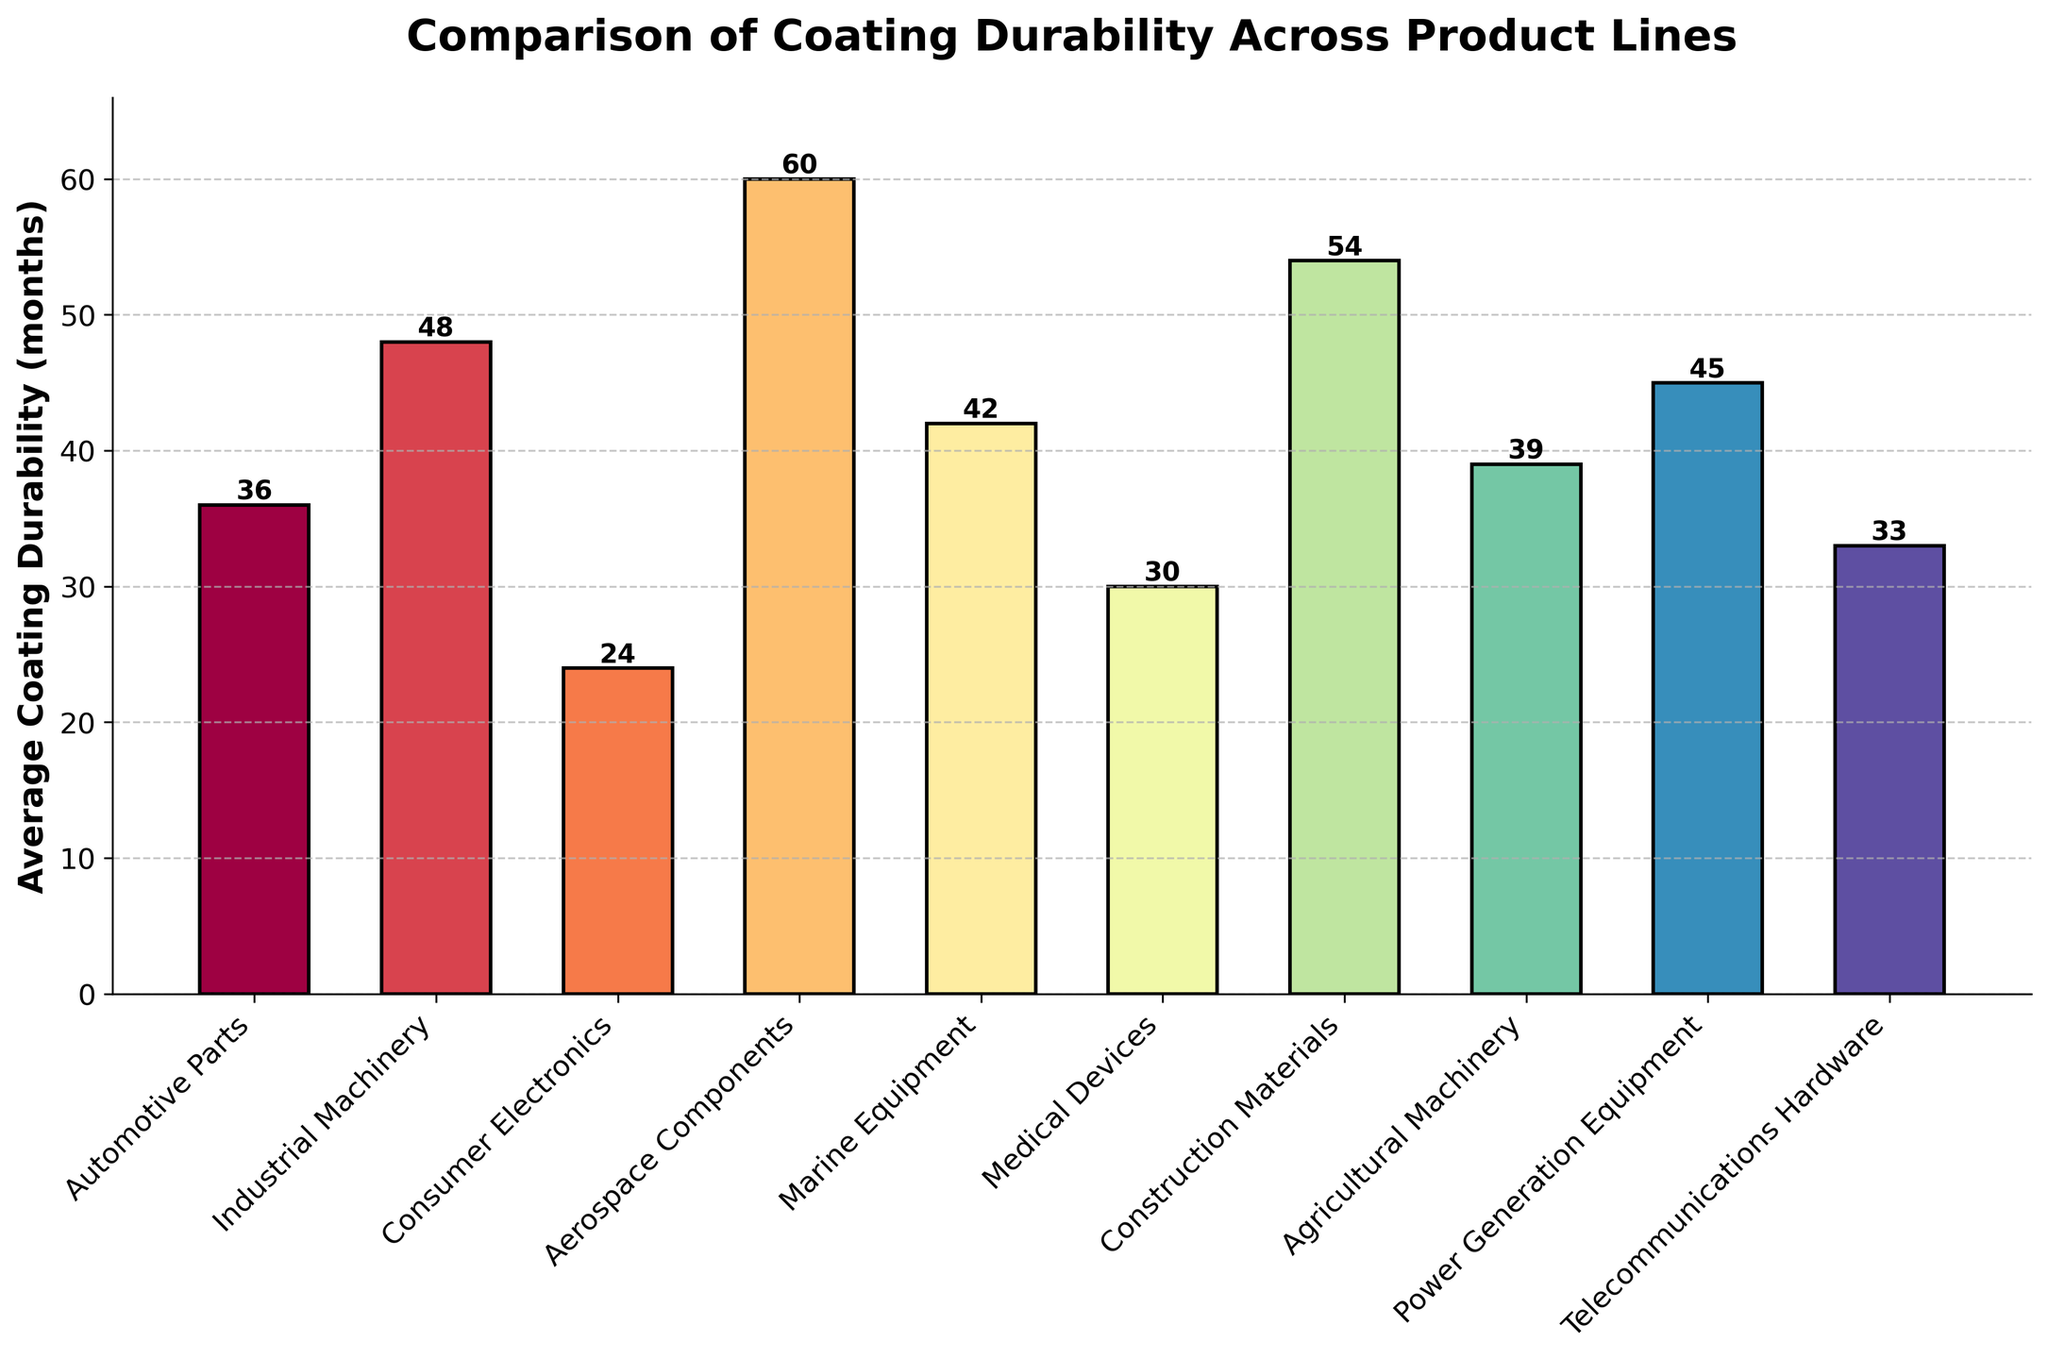Which product line has the highest average coating durability? Look for the product line with the tallest bar. The tallest bar represents Aerospace Components with 60 months.
Answer: Aerospace Components Which product line has the lowest average coating durability? Look for the product line with the shortest bar. The shortest bar represents Consumer Electronics with 24 months.
Answer: Consumer Electronics What is the difference in average coating durability between Marine Equipment and Automotive Parts? Marine Equipment has 42 months, and Automotive Parts has 36 months. The difference is 42 - 36 = 6 months.
Answer: 6 months How many months more durable on average are Aerospace Components compared to Consumer Electronics? Aerospace Components has 60 months, and Consumer Electronics has 24 months. The difference is 60 - 24 = 36 months.
Answer: 36 months Which product line has a higher average coating durability, Agricultural Machinery or Telecommunications Hardware? Compare the heights of the bars for Agricultural Machinery (39 months) and Telecommunications Hardware (33 months). Agricultural Machinery is taller.
Answer: Agricultural Machinery What is the average coating durability of Medical Devices, Construction Materials, and Power Generation Equipment combined? Sum the values: Medical Devices (30 months) + Construction Materials (54 months) + Power Generation Equipment (45 months) = 129 months. Divide by 3 for the average: 129 / 3 = 43 months.
Answer: 43 months Are there any product lines with an average coating durability exactly equal to 45 months? Look for a bar with a height of 45 months. Power Generation Equipment has 45 months.
Answer: Power Generation Equipment Rank the product lines from lowest to highest average coating durability. Order the bars from shortest to tallest: Consumer Electronics (24), Medical Devices (30), Telecommunications Hardware (33), Automotive Parts (36), Agricultural Machinery (39), Marine Equipment (42), Power Generation Equipment (45), Industrial Machinery (48), Construction Materials (54), Aerospace Components (60).
Answer: Consumer Electronics, Medical Devices, Telecommunications Hardware, Automotive Parts, Agricultural Machinery, Marine Equipment, Power Generation Equipment, Industrial Machinery, Construction Materials, Aerospace Components 